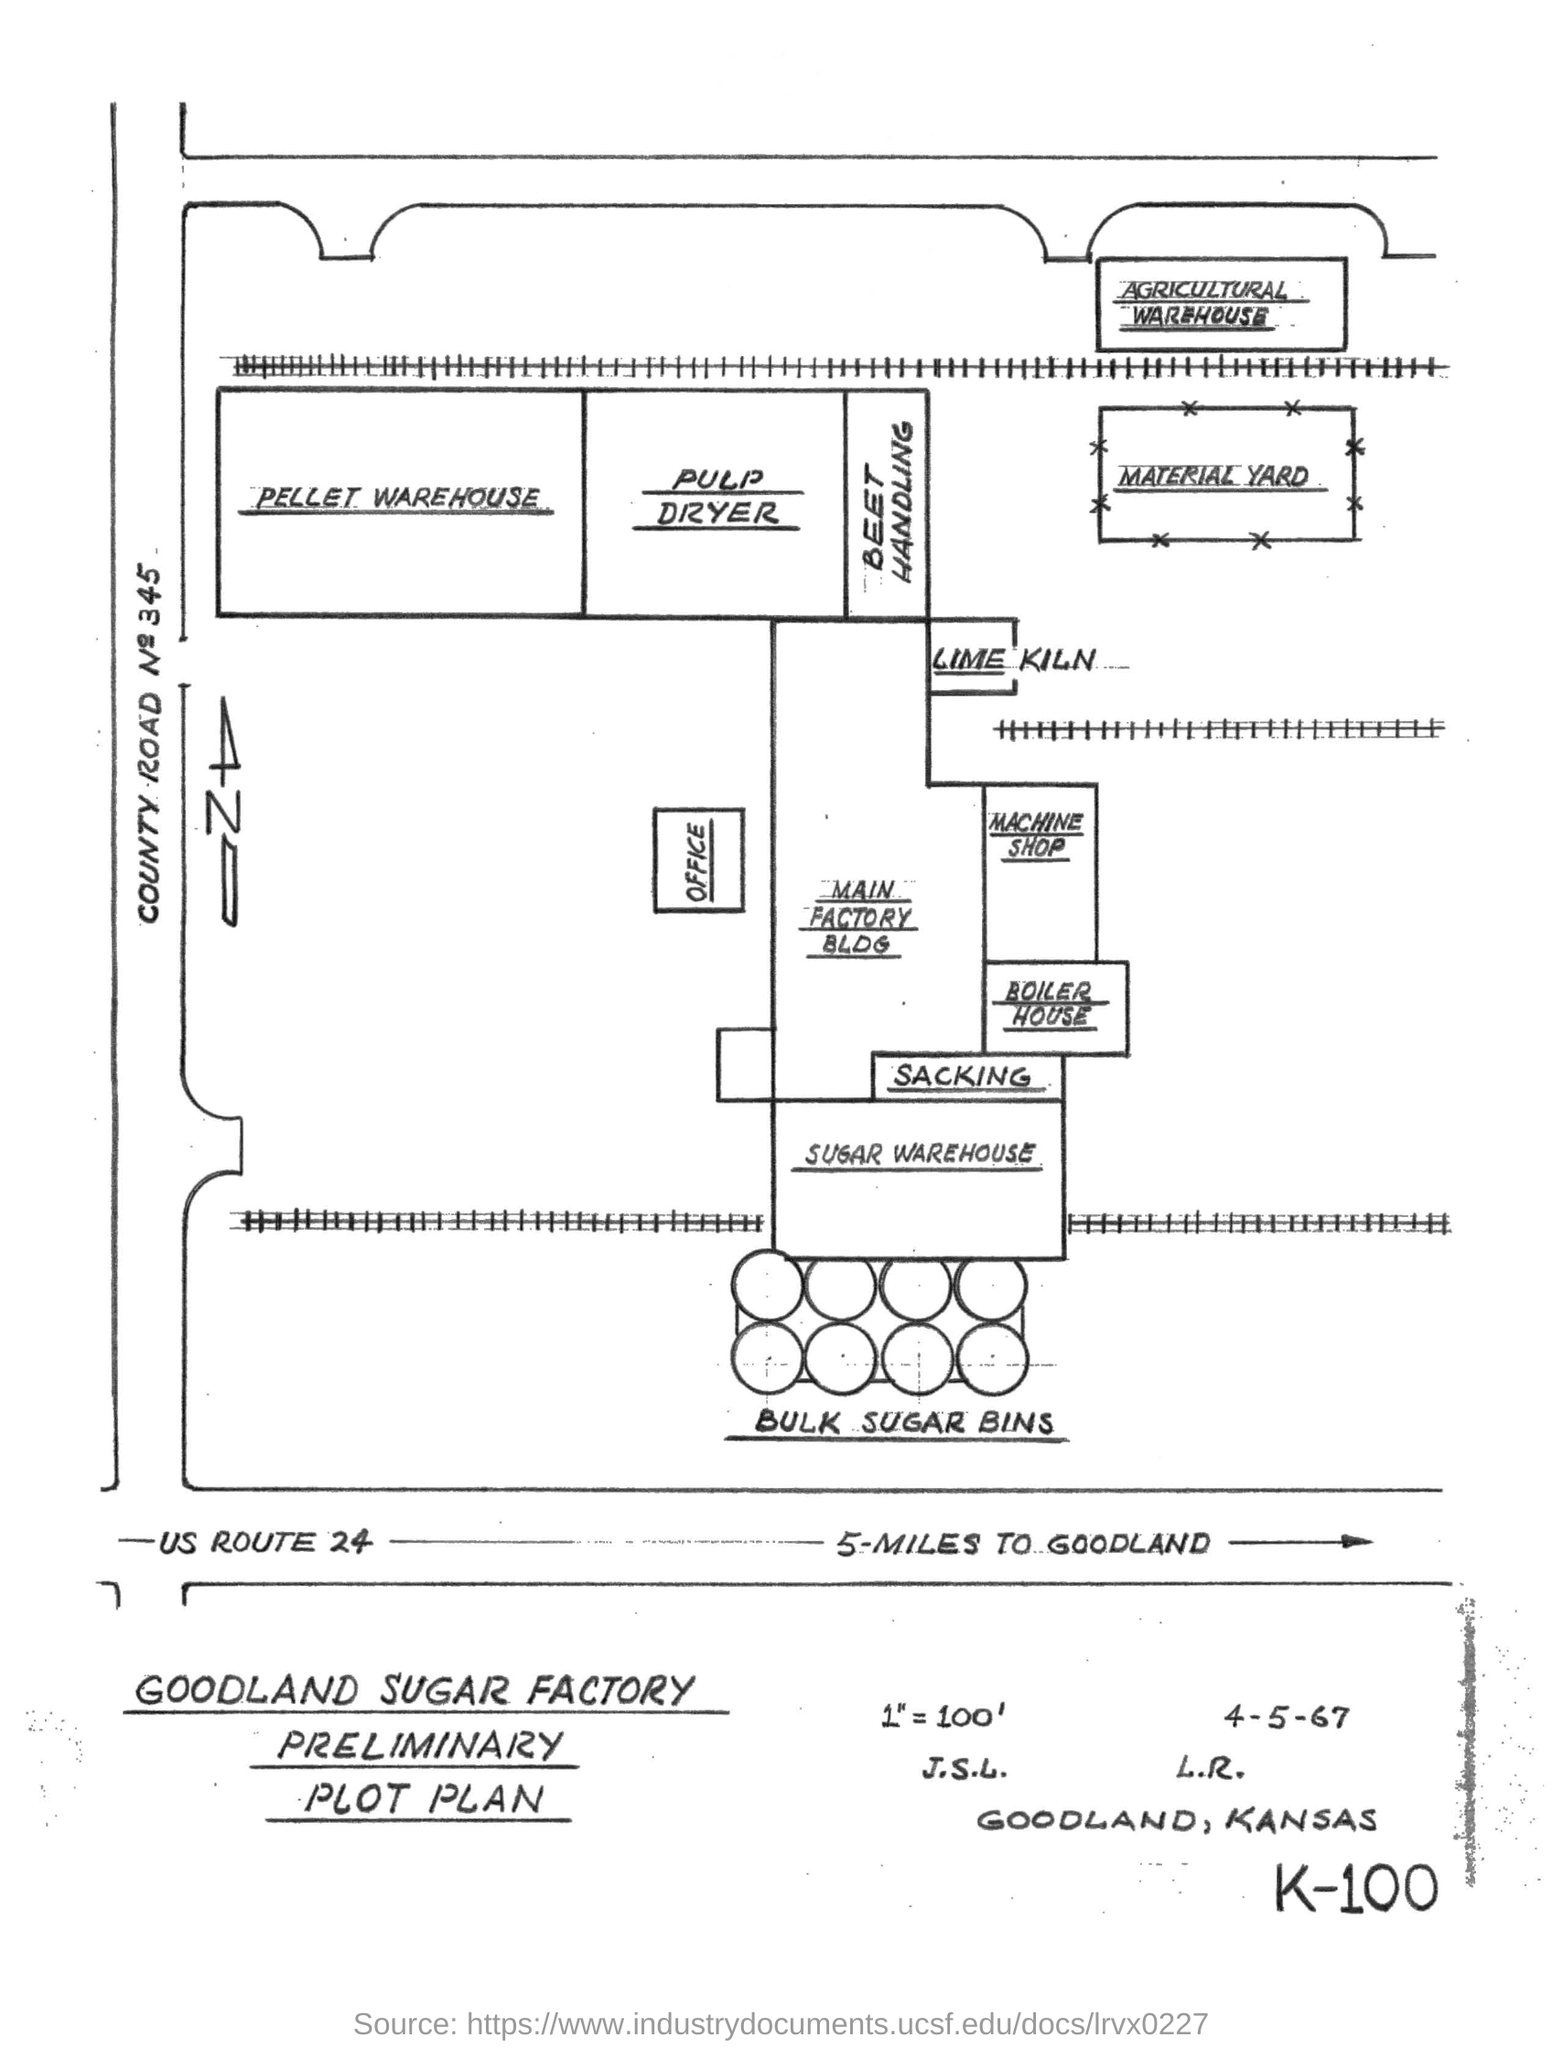Identify some key points in this picture. It is approximately 5 miles from the current location to GoodLand in US ROUTE 24. This is the preliminary plot plan of the Goodland Sugar Factory. 345 is the number of County Road. 